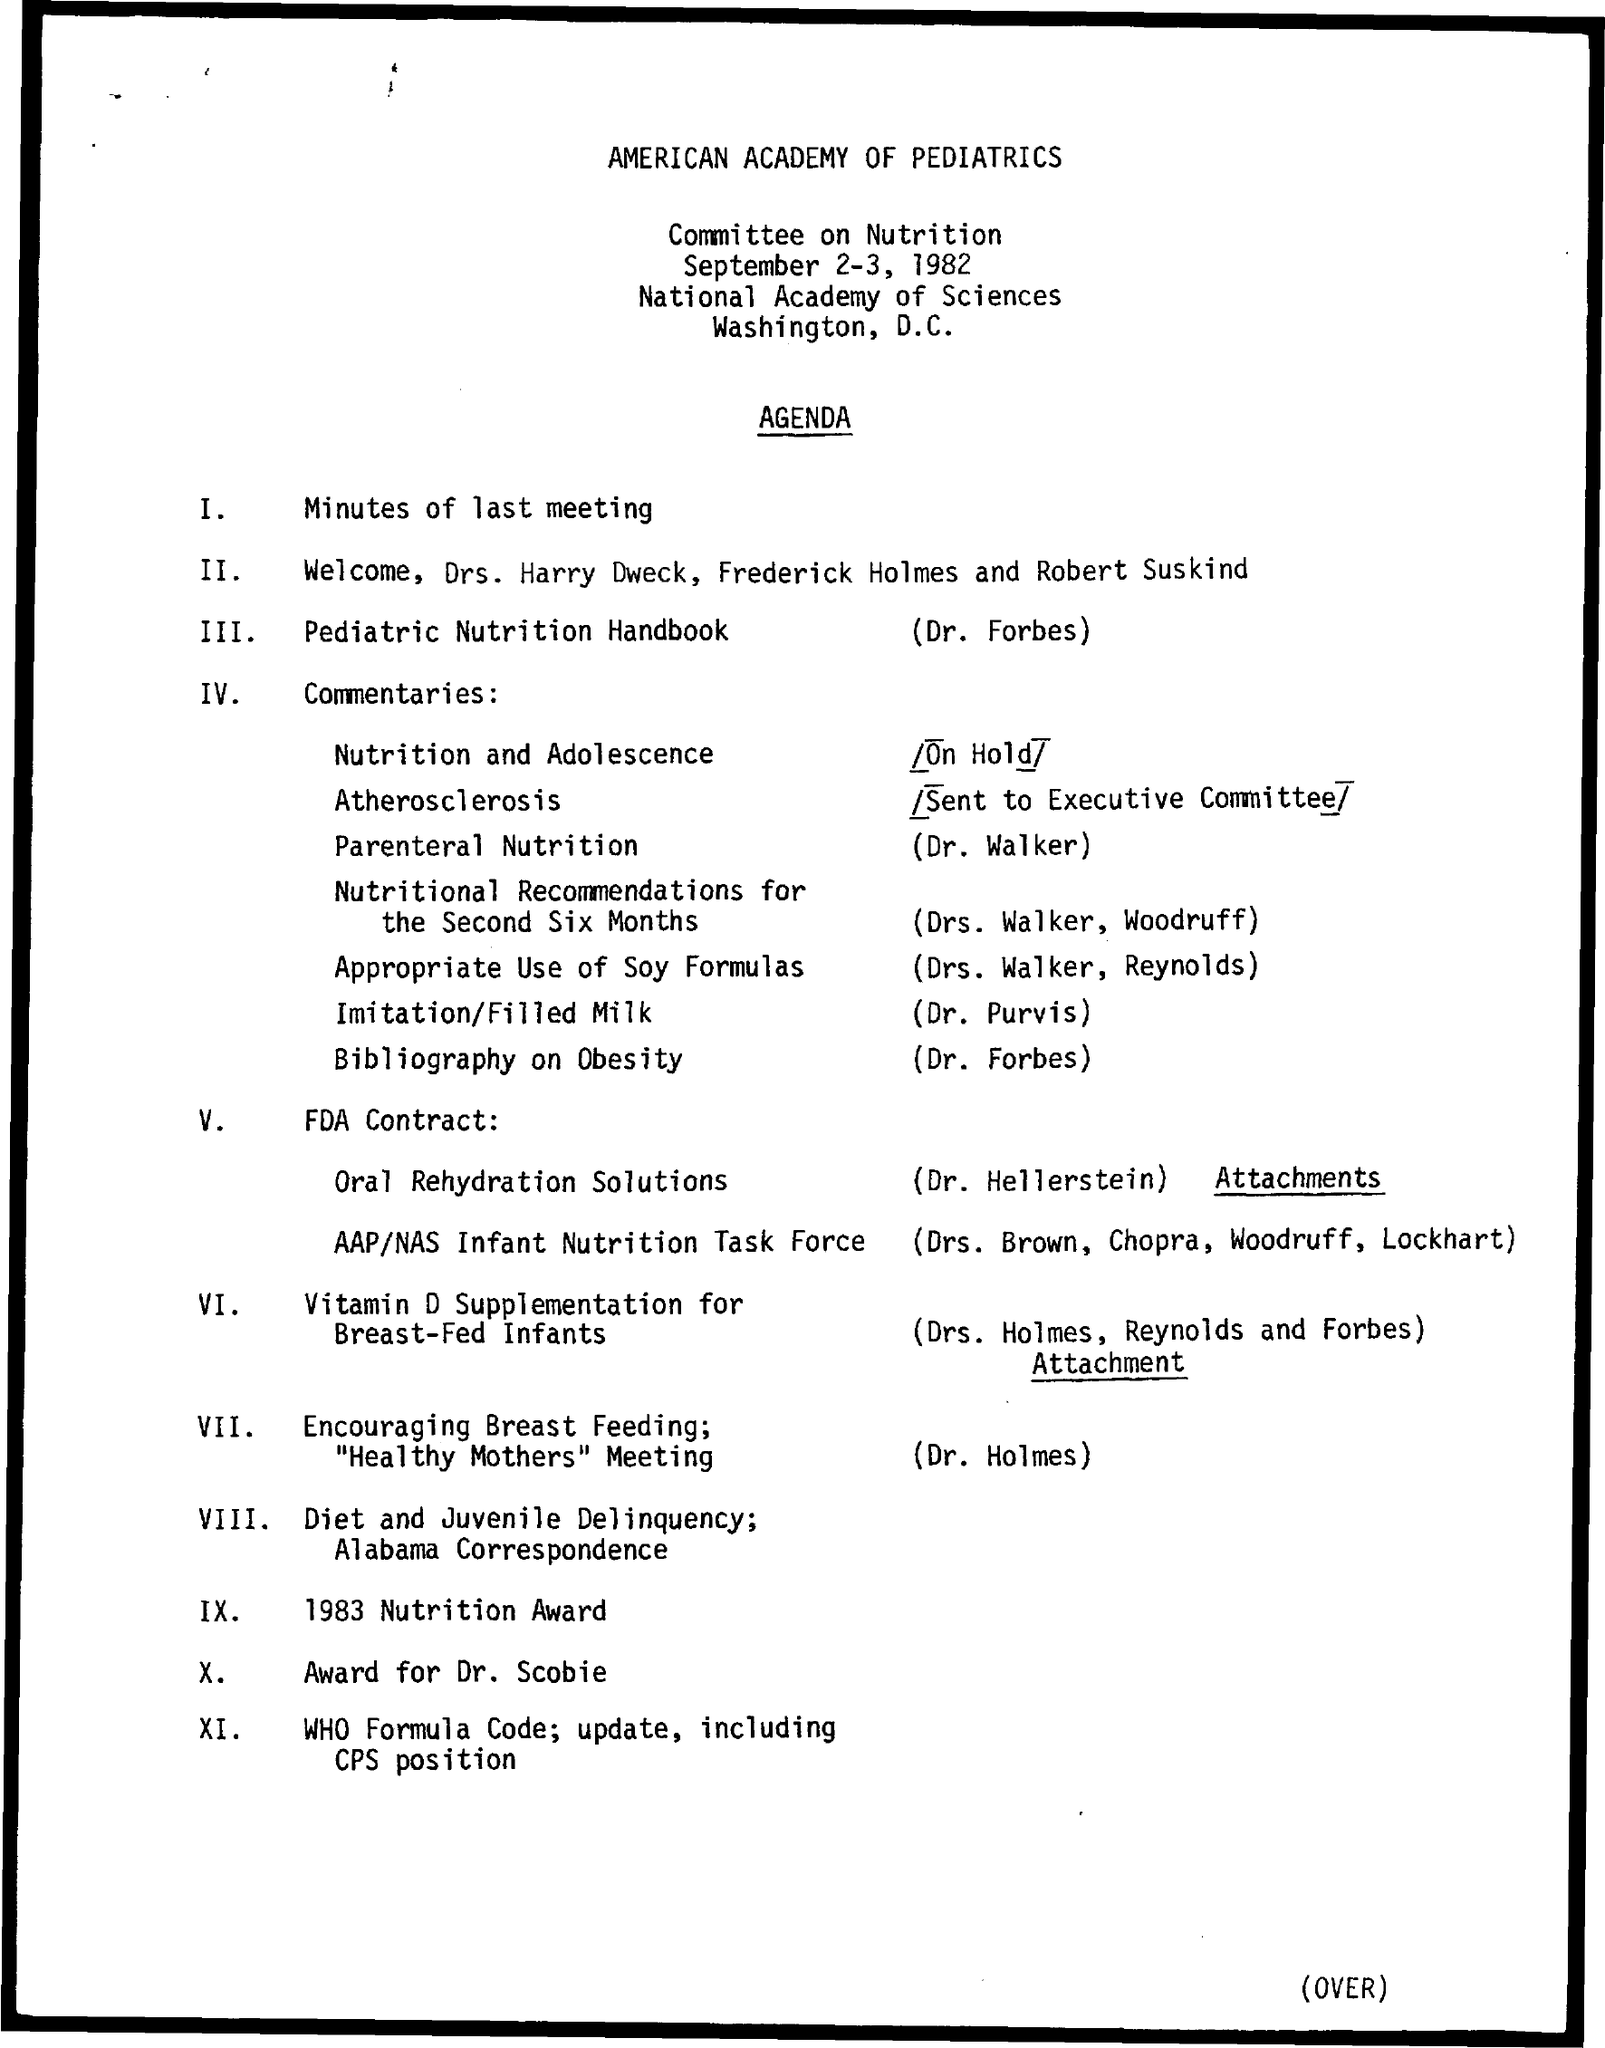What is the title of the document?
Make the answer very short. American Academy of Pediatrics. What is agenda number I?
Your answer should be very brief. Minutes of last meeting. What is agenda number IX?
Your response must be concise. 1983 Nutrition Award. What is agenda number X?
Ensure brevity in your answer.  Award for Dr. Scobie. What is agenda number III?
Make the answer very short. Pediatric Nutrition Handbook. 